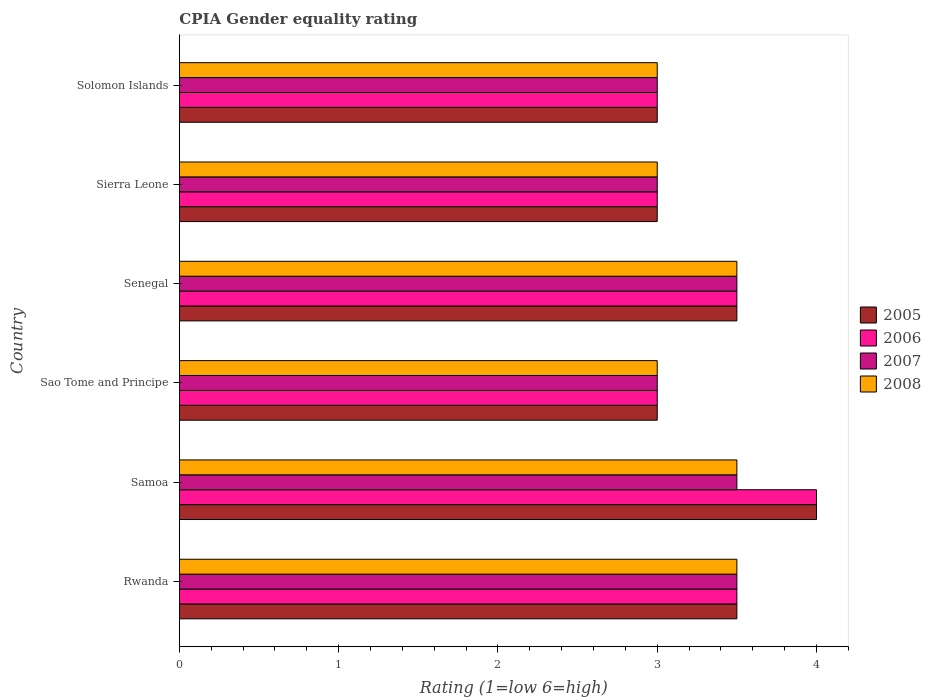How many bars are there on the 2nd tick from the top?
Make the answer very short. 4. What is the label of the 5th group of bars from the top?
Your response must be concise. Samoa. Across all countries, what is the maximum CPIA rating in 2005?
Your answer should be very brief. 4. Across all countries, what is the minimum CPIA rating in 2005?
Your answer should be very brief. 3. In which country was the CPIA rating in 2007 maximum?
Your answer should be very brief. Rwanda. In which country was the CPIA rating in 2006 minimum?
Your answer should be compact. Sao Tome and Principe. What is the total CPIA rating in 2008 in the graph?
Provide a succinct answer. 19.5. What is the difference between the CPIA rating in 2005 in Sao Tome and Principe and that in Solomon Islands?
Give a very brief answer. 0. What is the difference between the CPIA rating in 2005 in Rwanda and the CPIA rating in 2008 in Senegal?
Make the answer very short. 0. What is the average CPIA rating in 2005 per country?
Your answer should be compact. 3.33. In how many countries, is the CPIA rating in 2006 greater than 1.8 ?
Your answer should be compact. 6. What is the ratio of the CPIA rating in 2006 in Sao Tome and Principe to that in Senegal?
Ensure brevity in your answer.  0.86. Is the difference between the CPIA rating in 2007 in Senegal and Sierra Leone greater than the difference between the CPIA rating in 2008 in Senegal and Sierra Leone?
Your answer should be very brief. No. What is the difference between the highest and the lowest CPIA rating in 2008?
Offer a terse response. 0.5. In how many countries, is the CPIA rating in 2008 greater than the average CPIA rating in 2008 taken over all countries?
Give a very brief answer. 3. Is the sum of the CPIA rating in 2005 in Samoa and Sierra Leone greater than the maximum CPIA rating in 2008 across all countries?
Provide a succinct answer. Yes. Is it the case that in every country, the sum of the CPIA rating in 2005 and CPIA rating in 2006 is greater than the sum of CPIA rating in 2007 and CPIA rating in 2008?
Your answer should be very brief. No. What does the 2nd bar from the bottom in Sierra Leone represents?
Keep it short and to the point. 2006. How many bars are there?
Provide a succinct answer. 24. Are all the bars in the graph horizontal?
Offer a very short reply. Yes. How many countries are there in the graph?
Provide a short and direct response. 6. Does the graph contain any zero values?
Make the answer very short. No. Where does the legend appear in the graph?
Give a very brief answer. Center right. How many legend labels are there?
Ensure brevity in your answer.  4. What is the title of the graph?
Keep it short and to the point. CPIA Gender equality rating. What is the label or title of the X-axis?
Your answer should be compact. Rating (1=low 6=high). What is the Rating (1=low 6=high) in 2008 in Rwanda?
Provide a succinct answer. 3.5. What is the Rating (1=low 6=high) in 2005 in Samoa?
Provide a succinct answer. 4. What is the Rating (1=low 6=high) of 2005 in Sao Tome and Principe?
Your response must be concise. 3. What is the Rating (1=low 6=high) in 2006 in Sao Tome and Principe?
Provide a short and direct response. 3. What is the Rating (1=low 6=high) in 2008 in Sao Tome and Principe?
Make the answer very short. 3. What is the Rating (1=low 6=high) in 2005 in Senegal?
Your answer should be compact. 3.5. What is the Rating (1=low 6=high) of 2008 in Senegal?
Ensure brevity in your answer.  3.5. What is the Rating (1=low 6=high) of 2005 in Sierra Leone?
Ensure brevity in your answer.  3. What is the Rating (1=low 6=high) of 2008 in Sierra Leone?
Your answer should be very brief. 3. What is the Rating (1=low 6=high) in 2007 in Solomon Islands?
Make the answer very short. 3. What is the Rating (1=low 6=high) in 2008 in Solomon Islands?
Your answer should be compact. 3. Across all countries, what is the minimum Rating (1=low 6=high) in 2006?
Your response must be concise. 3. Across all countries, what is the minimum Rating (1=low 6=high) in 2007?
Your response must be concise. 3. Across all countries, what is the minimum Rating (1=low 6=high) in 2008?
Make the answer very short. 3. What is the total Rating (1=low 6=high) of 2006 in the graph?
Your response must be concise. 20. What is the total Rating (1=low 6=high) in 2008 in the graph?
Keep it short and to the point. 19.5. What is the difference between the Rating (1=low 6=high) of 2006 in Rwanda and that in Samoa?
Your answer should be compact. -0.5. What is the difference between the Rating (1=low 6=high) of 2008 in Rwanda and that in Samoa?
Provide a succinct answer. 0. What is the difference between the Rating (1=low 6=high) in 2005 in Rwanda and that in Sao Tome and Principe?
Make the answer very short. 0.5. What is the difference between the Rating (1=low 6=high) in 2006 in Rwanda and that in Sao Tome and Principe?
Provide a short and direct response. 0.5. What is the difference between the Rating (1=low 6=high) in 2007 in Rwanda and that in Sao Tome and Principe?
Offer a very short reply. 0.5. What is the difference between the Rating (1=low 6=high) of 2008 in Rwanda and that in Sao Tome and Principe?
Offer a very short reply. 0.5. What is the difference between the Rating (1=low 6=high) of 2005 in Rwanda and that in Senegal?
Offer a terse response. 0. What is the difference between the Rating (1=low 6=high) in 2005 in Rwanda and that in Sierra Leone?
Your answer should be compact. 0.5. What is the difference between the Rating (1=low 6=high) in 2008 in Rwanda and that in Sierra Leone?
Make the answer very short. 0.5. What is the difference between the Rating (1=low 6=high) in 2005 in Rwanda and that in Solomon Islands?
Make the answer very short. 0.5. What is the difference between the Rating (1=low 6=high) of 2006 in Rwanda and that in Solomon Islands?
Offer a terse response. 0.5. What is the difference between the Rating (1=low 6=high) in 2007 in Rwanda and that in Solomon Islands?
Your answer should be compact. 0.5. What is the difference between the Rating (1=low 6=high) in 2005 in Samoa and that in Sao Tome and Principe?
Give a very brief answer. 1. What is the difference between the Rating (1=low 6=high) of 2006 in Samoa and that in Sao Tome and Principe?
Your response must be concise. 1. What is the difference between the Rating (1=low 6=high) in 2007 in Samoa and that in Sao Tome and Principe?
Your response must be concise. 0.5. What is the difference between the Rating (1=low 6=high) in 2006 in Samoa and that in Senegal?
Keep it short and to the point. 0.5. What is the difference between the Rating (1=low 6=high) in 2008 in Samoa and that in Senegal?
Ensure brevity in your answer.  0. What is the difference between the Rating (1=low 6=high) in 2005 in Samoa and that in Sierra Leone?
Your answer should be compact. 1. What is the difference between the Rating (1=low 6=high) in 2006 in Samoa and that in Sierra Leone?
Your answer should be very brief. 1. What is the difference between the Rating (1=low 6=high) in 2008 in Samoa and that in Sierra Leone?
Give a very brief answer. 0.5. What is the difference between the Rating (1=low 6=high) in 2005 in Samoa and that in Solomon Islands?
Your answer should be very brief. 1. What is the difference between the Rating (1=low 6=high) of 2006 in Samoa and that in Solomon Islands?
Your answer should be very brief. 1. What is the difference between the Rating (1=low 6=high) in 2007 in Samoa and that in Solomon Islands?
Make the answer very short. 0.5. What is the difference between the Rating (1=low 6=high) of 2008 in Samoa and that in Solomon Islands?
Offer a very short reply. 0.5. What is the difference between the Rating (1=low 6=high) in 2007 in Sao Tome and Principe and that in Senegal?
Give a very brief answer. -0.5. What is the difference between the Rating (1=low 6=high) in 2006 in Sao Tome and Principe and that in Sierra Leone?
Your response must be concise. 0. What is the difference between the Rating (1=low 6=high) in 2008 in Sao Tome and Principe and that in Sierra Leone?
Ensure brevity in your answer.  0. What is the difference between the Rating (1=low 6=high) in 2005 in Sao Tome and Principe and that in Solomon Islands?
Ensure brevity in your answer.  0. What is the difference between the Rating (1=low 6=high) in 2006 in Sao Tome and Principe and that in Solomon Islands?
Make the answer very short. 0. What is the difference between the Rating (1=low 6=high) in 2007 in Sao Tome and Principe and that in Solomon Islands?
Your answer should be very brief. 0. What is the difference between the Rating (1=low 6=high) of 2008 in Sao Tome and Principe and that in Solomon Islands?
Make the answer very short. 0. What is the difference between the Rating (1=low 6=high) in 2005 in Senegal and that in Sierra Leone?
Your answer should be very brief. 0.5. What is the difference between the Rating (1=low 6=high) of 2007 in Senegal and that in Sierra Leone?
Make the answer very short. 0.5. What is the difference between the Rating (1=low 6=high) in 2008 in Senegal and that in Sierra Leone?
Provide a succinct answer. 0.5. What is the difference between the Rating (1=low 6=high) in 2005 in Senegal and that in Solomon Islands?
Ensure brevity in your answer.  0.5. What is the difference between the Rating (1=low 6=high) of 2006 in Senegal and that in Solomon Islands?
Ensure brevity in your answer.  0.5. What is the difference between the Rating (1=low 6=high) of 2007 in Senegal and that in Solomon Islands?
Offer a very short reply. 0.5. What is the difference between the Rating (1=low 6=high) in 2007 in Sierra Leone and that in Solomon Islands?
Offer a terse response. 0. What is the difference between the Rating (1=low 6=high) in 2005 in Rwanda and the Rating (1=low 6=high) in 2006 in Samoa?
Provide a succinct answer. -0.5. What is the difference between the Rating (1=low 6=high) in 2005 in Rwanda and the Rating (1=low 6=high) in 2008 in Samoa?
Provide a succinct answer. 0. What is the difference between the Rating (1=low 6=high) of 2007 in Rwanda and the Rating (1=low 6=high) of 2008 in Samoa?
Ensure brevity in your answer.  0. What is the difference between the Rating (1=low 6=high) in 2005 in Rwanda and the Rating (1=low 6=high) in 2006 in Sao Tome and Principe?
Offer a very short reply. 0.5. What is the difference between the Rating (1=low 6=high) in 2005 in Rwanda and the Rating (1=low 6=high) in 2007 in Sao Tome and Principe?
Your response must be concise. 0.5. What is the difference between the Rating (1=low 6=high) of 2005 in Rwanda and the Rating (1=low 6=high) of 2008 in Sao Tome and Principe?
Your response must be concise. 0.5. What is the difference between the Rating (1=low 6=high) in 2007 in Rwanda and the Rating (1=low 6=high) in 2008 in Sao Tome and Principe?
Make the answer very short. 0.5. What is the difference between the Rating (1=low 6=high) in 2005 in Rwanda and the Rating (1=low 6=high) in 2008 in Senegal?
Provide a succinct answer. 0. What is the difference between the Rating (1=low 6=high) in 2006 in Rwanda and the Rating (1=low 6=high) in 2007 in Senegal?
Ensure brevity in your answer.  0. What is the difference between the Rating (1=low 6=high) in 2006 in Rwanda and the Rating (1=low 6=high) in 2008 in Senegal?
Your answer should be compact. 0. What is the difference between the Rating (1=low 6=high) in 2005 in Rwanda and the Rating (1=low 6=high) in 2007 in Sierra Leone?
Give a very brief answer. 0.5. What is the difference between the Rating (1=low 6=high) of 2005 in Rwanda and the Rating (1=low 6=high) of 2008 in Sierra Leone?
Offer a terse response. 0.5. What is the difference between the Rating (1=low 6=high) in 2006 in Rwanda and the Rating (1=low 6=high) in 2008 in Sierra Leone?
Provide a succinct answer. 0.5. What is the difference between the Rating (1=low 6=high) in 2007 in Rwanda and the Rating (1=low 6=high) in 2008 in Sierra Leone?
Provide a succinct answer. 0.5. What is the difference between the Rating (1=low 6=high) in 2005 in Rwanda and the Rating (1=low 6=high) in 2008 in Solomon Islands?
Your answer should be very brief. 0.5. What is the difference between the Rating (1=low 6=high) in 2005 in Samoa and the Rating (1=low 6=high) in 2007 in Sao Tome and Principe?
Make the answer very short. 1. What is the difference between the Rating (1=low 6=high) in 2006 in Samoa and the Rating (1=low 6=high) in 2007 in Sao Tome and Principe?
Keep it short and to the point. 1. What is the difference between the Rating (1=low 6=high) of 2006 in Samoa and the Rating (1=low 6=high) of 2008 in Sao Tome and Principe?
Provide a succinct answer. 1. What is the difference between the Rating (1=low 6=high) of 2007 in Samoa and the Rating (1=low 6=high) of 2008 in Sao Tome and Principe?
Provide a short and direct response. 0.5. What is the difference between the Rating (1=low 6=high) in 2005 in Samoa and the Rating (1=low 6=high) in 2006 in Senegal?
Offer a very short reply. 0.5. What is the difference between the Rating (1=low 6=high) of 2005 in Samoa and the Rating (1=low 6=high) of 2007 in Senegal?
Keep it short and to the point. 0.5. What is the difference between the Rating (1=low 6=high) in 2006 in Samoa and the Rating (1=low 6=high) in 2008 in Senegal?
Your response must be concise. 0.5. What is the difference between the Rating (1=low 6=high) of 2007 in Samoa and the Rating (1=low 6=high) of 2008 in Senegal?
Offer a very short reply. 0. What is the difference between the Rating (1=low 6=high) in 2005 in Samoa and the Rating (1=low 6=high) in 2006 in Sierra Leone?
Make the answer very short. 1. What is the difference between the Rating (1=low 6=high) in 2005 in Samoa and the Rating (1=low 6=high) in 2007 in Sierra Leone?
Your answer should be compact. 1. What is the difference between the Rating (1=low 6=high) of 2005 in Samoa and the Rating (1=low 6=high) of 2008 in Sierra Leone?
Keep it short and to the point. 1. What is the difference between the Rating (1=low 6=high) in 2006 in Samoa and the Rating (1=low 6=high) in 2007 in Sierra Leone?
Make the answer very short. 1. What is the difference between the Rating (1=low 6=high) of 2005 in Samoa and the Rating (1=low 6=high) of 2007 in Solomon Islands?
Keep it short and to the point. 1. What is the difference between the Rating (1=low 6=high) in 2006 in Samoa and the Rating (1=low 6=high) in 2007 in Solomon Islands?
Offer a very short reply. 1. What is the difference between the Rating (1=low 6=high) of 2006 in Samoa and the Rating (1=low 6=high) of 2008 in Solomon Islands?
Your answer should be very brief. 1. What is the difference between the Rating (1=low 6=high) of 2007 in Samoa and the Rating (1=low 6=high) of 2008 in Solomon Islands?
Make the answer very short. 0.5. What is the difference between the Rating (1=low 6=high) of 2005 in Sao Tome and Principe and the Rating (1=low 6=high) of 2006 in Senegal?
Provide a succinct answer. -0.5. What is the difference between the Rating (1=low 6=high) of 2005 in Sao Tome and Principe and the Rating (1=low 6=high) of 2008 in Senegal?
Make the answer very short. -0.5. What is the difference between the Rating (1=low 6=high) of 2006 in Sao Tome and Principe and the Rating (1=low 6=high) of 2008 in Senegal?
Keep it short and to the point. -0.5. What is the difference between the Rating (1=low 6=high) of 2007 in Sao Tome and Principe and the Rating (1=low 6=high) of 2008 in Senegal?
Your response must be concise. -0.5. What is the difference between the Rating (1=low 6=high) of 2005 in Sao Tome and Principe and the Rating (1=low 6=high) of 2007 in Sierra Leone?
Offer a terse response. 0. What is the difference between the Rating (1=low 6=high) of 2006 in Sao Tome and Principe and the Rating (1=low 6=high) of 2007 in Sierra Leone?
Your response must be concise. 0. What is the difference between the Rating (1=low 6=high) in 2006 in Sao Tome and Principe and the Rating (1=low 6=high) in 2008 in Sierra Leone?
Your answer should be very brief. 0. What is the difference between the Rating (1=low 6=high) in 2007 in Sao Tome and Principe and the Rating (1=low 6=high) in 2008 in Sierra Leone?
Keep it short and to the point. 0. What is the difference between the Rating (1=low 6=high) of 2005 in Sao Tome and Principe and the Rating (1=low 6=high) of 2006 in Solomon Islands?
Give a very brief answer. 0. What is the difference between the Rating (1=low 6=high) of 2005 in Sao Tome and Principe and the Rating (1=low 6=high) of 2007 in Solomon Islands?
Your answer should be very brief. 0. What is the difference between the Rating (1=low 6=high) in 2005 in Sao Tome and Principe and the Rating (1=low 6=high) in 2008 in Solomon Islands?
Make the answer very short. 0. What is the difference between the Rating (1=low 6=high) in 2006 in Sao Tome and Principe and the Rating (1=low 6=high) in 2007 in Solomon Islands?
Offer a terse response. 0. What is the difference between the Rating (1=low 6=high) in 2007 in Sao Tome and Principe and the Rating (1=low 6=high) in 2008 in Solomon Islands?
Ensure brevity in your answer.  0. What is the difference between the Rating (1=low 6=high) of 2005 in Senegal and the Rating (1=low 6=high) of 2007 in Sierra Leone?
Your answer should be very brief. 0.5. What is the difference between the Rating (1=low 6=high) of 2006 in Senegal and the Rating (1=low 6=high) of 2008 in Sierra Leone?
Ensure brevity in your answer.  0.5. What is the difference between the Rating (1=low 6=high) of 2007 in Senegal and the Rating (1=low 6=high) of 2008 in Sierra Leone?
Your answer should be very brief. 0.5. What is the difference between the Rating (1=low 6=high) of 2005 in Senegal and the Rating (1=low 6=high) of 2006 in Solomon Islands?
Provide a short and direct response. 0.5. What is the difference between the Rating (1=low 6=high) of 2005 in Senegal and the Rating (1=low 6=high) of 2007 in Solomon Islands?
Provide a succinct answer. 0.5. What is the difference between the Rating (1=low 6=high) of 2005 in Sierra Leone and the Rating (1=low 6=high) of 2007 in Solomon Islands?
Your answer should be very brief. 0. What is the difference between the Rating (1=low 6=high) of 2006 in Sierra Leone and the Rating (1=low 6=high) of 2008 in Solomon Islands?
Give a very brief answer. 0. What is the average Rating (1=low 6=high) of 2005 per country?
Your response must be concise. 3.33. What is the average Rating (1=low 6=high) in 2006 per country?
Offer a terse response. 3.33. What is the average Rating (1=low 6=high) of 2007 per country?
Your answer should be compact. 3.25. What is the average Rating (1=low 6=high) in 2008 per country?
Offer a very short reply. 3.25. What is the difference between the Rating (1=low 6=high) of 2005 and Rating (1=low 6=high) of 2006 in Rwanda?
Provide a short and direct response. 0. What is the difference between the Rating (1=low 6=high) of 2005 and Rating (1=low 6=high) of 2007 in Rwanda?
Ensure brevity in your answer.  0. What is the difference between the Rating (1=low 6=high) of 2006 and Rating (1=low 6=high) of 2007 in Rwanda?
Your answer should be compact. 0. What is the difference between the Rating (1=low 6=high) in 2006 and Rating (1=low 6=high) in 2008 in Rwanda?
Make the answer very short. 0. What is the difference between the Rating (1=low 6=high) of 2005 and Rating (1=low 6=high) of 2006 in Samoa?
Offer a very short reply. 0. What is the difference between the Rating (1=low 6=high) of 2005 and Rating (1=low 6=high) of 2007 in Samoa?
Your answer should be very brief. 0.5. What is the difference between the Rating (1=low 6=high) of 2005 and Rating (1=low 6=high) of 2008 in Samoa?
Your response must be concise. 0.5. What is the difference between the Rating (1=low 6=high) in 2007 and Rating (1=low 6=high) in 2008 in Samoa?
Ensure brevity in your answer.  0. What is the difference between the Rating (1=low 6=high) of 2005 and Rating (1=low 6=high) of 2008 in Sao Tome and Principe?
Make the answer very short. 0. What is the difference between the Rating (1=low 6=high) of 2007 and Rating (1=low 6=high) of 2008 in Sao Tome and Principe?
Your answer should be compact. 0. What is the difference between the Rating (1=low 6=high) in 2005 and Rating (1=low 6=high) in 2006 in Senegal?
Your answer should be compact. 0. What is the difference between the Rating (1=low 6=high) in 2006 and Rating (1=low 6=high) in 2008 in Senegal?
Keep it short and to the point. 0. What is the difference between the Rating (1=low 6=high) in 2007 and Rating (1=low 6=high) in 2008 in Senegal?
Make the answer very short. 0. What is the difference between the Rating (1=low 6=high) in 2005 and Rating (1=low 6=high) in 2006 in Sierra Leone?
Offer a terse response. 0. What is the difference between the Rating (1=low 6=high) in 2005 and Rating (1=low 6=high) in 2007 in Sierra Leone?
Keep it short and to the point. 0. What is the difference between the Rating (1=low 6=high) of 2005 and Rating (1=low 6=high) of 2008 in Sierra Leone?
Ensure brevity in your answer.  0. What is the difference between the Rating (1=low 6=high) of 2006 and Rating (1=low 6=high) of 2007 in Solomon Islands?
Give a very brief answer. 0. What is the difference between the Rating (1=low 6=high) of 2006 and Rating (1=low 6=high) of 2008 in Solomon Islands?
Make the answer very short. 0. What is the difference between the Rating (1=low 6=high) in 2007 and Rating (1=low 6=high) in 2008 in Solomon Islands?
Offer a very short reply. 0. What is the ratio of the Rating (1=low 6=high) of 2005 in Rwanda to that in Samoa?
Provide a short and direct response. 0.88. What is the ratio of the Rating (1=low 6=high) of 2006 in Rwanda to that in Samoa?
Keep it short and to the point. 0.88. What is the ratio of the Rating (1=low 6=high) of 2007 in Rwanda to that in Samoa?
Offer a very short reply. 1. What is the ratio of the Rating (1=low 6=high) in 2006 in Rwanda to that in Sao Tome and Principe?
Your answer should be compact. 1.17. What is the ratio of the Rating (1=low 6=high) of 2007 in Rwanda to that in Sao Tome and Principe?
Your answer should be compact. 1.17. What is the ratio of the Rating (1=low 6=high) of 2008 in Rwanda to that in Sao Tome and Principe?
Your response must be concise. 1.17. What is the ratio of the Rating (1=low 6=high) in 2005 in Rwanda to that in Senegal?
Your response must be concise. 1. What is the ratio of the Rating (1=low 6=high) of 2005 in Rwanda to that in Sierra Leone?
Make the answer very short. 1.17. What is the ratio of the Rating (1=low 6=high) in 2006 in Rwanda to that in Sierra Leone?
Give a very brief answer. 1.17. What is the ratio of the Rating (1=low 6=high) of 2007 in Rwanda to that in Sierra Leone?
Offer a terse response. 1.17. What is the ratio of the Rating (1=low 6=high) of 2008 in Rwanda to that in Sierra Leone?
Give a very brief answer. 1.17. What is the ratio of the Rating (1=low 6=high) in 2007 in Rwanda to that in Solomon Islands?
Your response must be concise. 1.17. What is the ratio of the Rating (1=low 6=high) of 2005 in Samoa to that in Senegal?
Make the answer very short. 1.14. What is the ratio of the Rating (1=low 6=high) in 2006 in Samoa to that in Senegal?
Ensure brevity in your answer.  1.14. What is the ratio of the Rating (1=low 6=high) of 2005 in Samoa to that in Sierra Leone?
Your answer should be compact. 1.33. What is the ratio of the Rating (1=low 6=high) of 2006 in Samoa to that in Sierra Leone?
Your answer should be compact. 1.33. What is the ratio of the Rating (1=low 6=high) of 2008 in Samoa to that in Sierra Leone?
Give a very brief answer. 1.17. What is the ratio of the Rating (1=low 6=high) in 2005 in Samoa to that in Solomon Islands?
Your answer should be very brief. 1.33. What is the ratio of the Rating (1=low 6=high) of 2008 in Samoa to that in Solomon Islands?
Offer a very short reply. 1.17. What is the ratio of the Rating (1=low 6=high) in 2005 in Sao Tome and Principe to that in Senegal?
Provide a succinct answer. 0.86. What is the ratio of the Rating (1=low 6=high) in 2006 in Sao Tome and Principe to that in Senegal?
Provide a short and direct response. 0.86. What is the ratio of the Rating (1=low 6=high) in 2007 in Sao Tome and Principe to that in Senegal?
Your response must be concise. 0.86. What is the ratio of the Rating (1=low 6=high) in 2006 in Sao Tome and Principe to that in Sierra Leone?
Keep it short and to the point. 1. What is the ratio of the Rating (1=low 6=high) in 2008 in Sao Tome and Principe to that in Sierra Leone?
Your answer should be compact. 1. What is the ratio of the Rating (1=low 6=high) of 2005 in Sao Tome and Principe to that in Solomon Islands?
Keep it short and to the point. 1. What is the ratio of the Rating (1=low 6=high) of 2007 in Sao Tome and Principe to that in Solomon Islands?
Your answer should be compact. 1. What is the ratio of the Rating (1=low 6=high) of 2007 in Senegal to that in Sierra Leone?
Give a very brief answer. 1.17. What is the ratio of the Rating (1=low 6=high) of 2008 in Senegal to that in Sierra Leone?
Your answer should be very brief. 1.17. What is the ratio of the Rating (1=low 6=high) of 2005 in Senegal to that in Solomon Islands?
Offer a terse response. 1.17. What is the ratio of the Rating (1=low 6=high) in 2008 in Senegal to that in Solomon Islands?
Make the answer very short. 1.17. What is the ratio of the Rating (1=low 6=high) in 2005 in Sierra Leone to that in Solomon Islands?
Offer a very short reply. 1. What is the ratio of the Rating (1=low 6=high) in 2006 in Sierra Leone to that in Solomon Islands?
Offer a very short reply. 1. What is the difference between the highest and the second highest Rating (1=low 6=high) of 2005?
Offer a terse response. 0.5. What is the difference between the highest and the lowest Rating (1=low 6=high) in 2005?
Your response must be concise. 1. What is the difference between the highest and the lowest Rating (1=low 6=high) of 2008?
Your response must be concise. 0.5. 